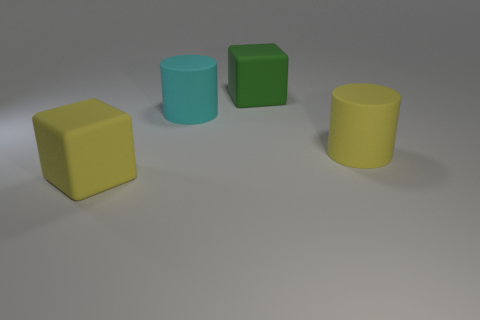Add 2 matte cubes. How many objects exist? 6 Subtract all matte cubes. Subtract all tiny blue cubes. How many objects are left? 2 Add 4 large yellow objects. How many large yellow objects are left? 6 Add 1 tiny gray matte cylinders. How many tiny gray matte cylinders exist? 1 Subtract 1 cyan cylinders. How many objects are left? 3 